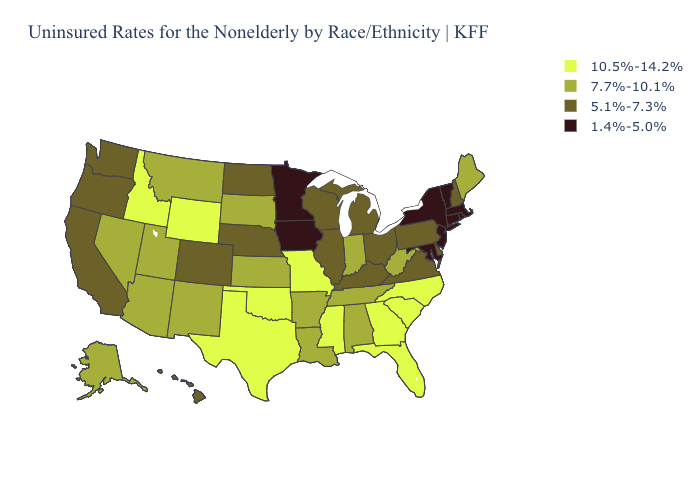Name the states that have a value in the range 7.7%-10.1%?
Short answer required. Alabama, Alaska, Arizona, Arkansas, Indiana, Kansas, Louisiana, Maine, Montana, Nevada, New Mexico, South Dakota, Tennessee, Utah, West Virginia. What is the value of Indiana?
Answer briefly. 7.7%-10.1%. Name the states that have a value in the range 10.5%-14.2%?
Short answer required. Florida, Georgia, Idaho, Mississippi, Missouri, North Carolina, Oklahoma, South Carolina, Texas, Wyoming. What is the value of Kansas?
Be succinct. 7.7%-10.1%. Does the first symbol in the legend represent the smallest category?
Give a very brief answer. No. What is the highest value in the West ?
Be succinct. 10.5%-14.2%. Which states have the highest value in the USA?
Be succinct. Florida, Georgia, Idaho, Mississippi, Missouri, North Carolina, Oklahoma, South Carolina, Texas, Wyoming. What is the lowest value in states that border California?
Quick response, please. 5.1%-7.3%. Name the states that have a value in the range 5.1%-7.3%?
Answer briefly. California, Colorado, Delaware, Hawaii, Illinois, Kentucky, Michigan, Nebraska, New Hampshire, North Dakota, Ohio, Oregon, Pennsylvania, Virginia, Washington, Wisconsin. Name the states that have a value in the range 1.4%-5.0%?
Short answer required. Connecticut, Iowa, Maryland, Massachusetts, Minnesota, New Jersey, New York, Rhode Island, Vermont. Does Wyoming have the highest value in the West?
Be succinct. Yes. Does California have the highest value in the USA?
Write a very short answer. No. Does North Carolina have the highest value in the USA?
Write a very short answer. Yes. Does Oregon have the same value as New Jersey?
Short answer required. No. What is the lowest value in the Northeast?
Give a very brief answer. 1.4%-5.0%. 